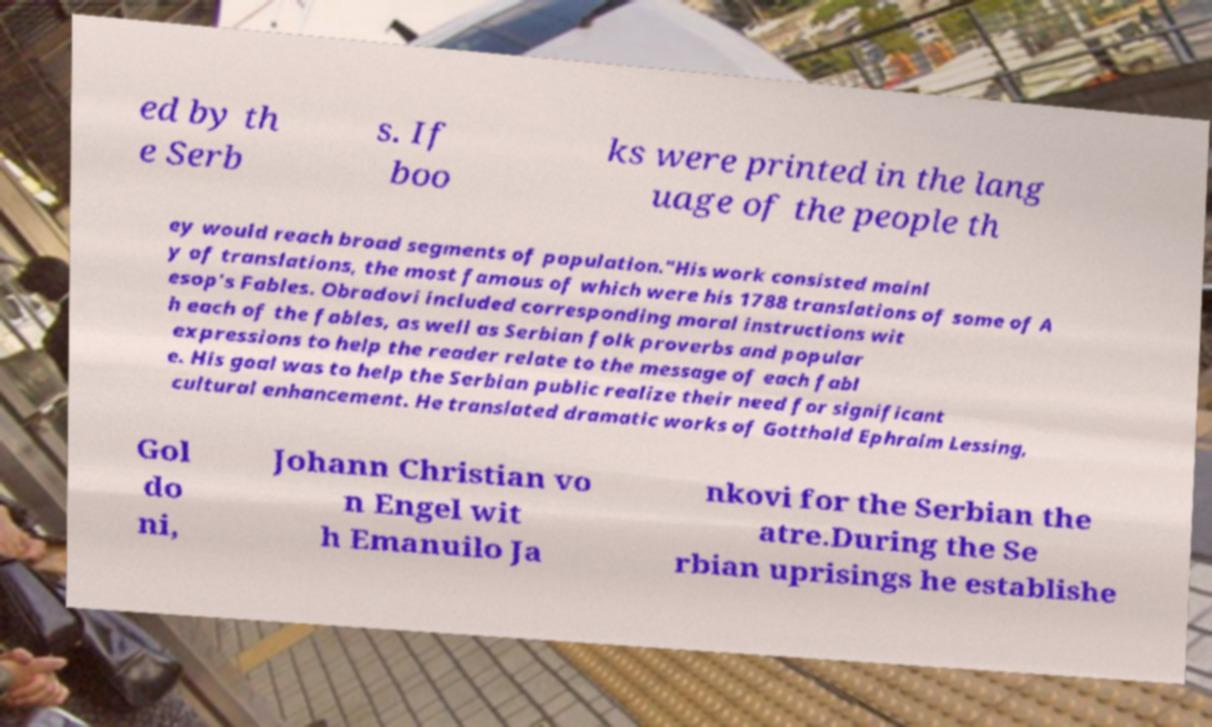Could you assist in decoding the text presented in this image and type it out clearly? ed by th e Serb s. If boo ks were printed in the lang uage of the people th ey would reach broad segments of population."His work consisted mainl y of translations, the most famous of which were his 1788 translations of some of A esop's Fables. Obradovi included corresponding moral instructions wit h each of the fables, as well as Serbian folk proverbs and popular expressions to help the reader relate to the message of each fabl e. His goal was to help the Serbian public realize their need for significant cultural enhancement. He translated dramatic works of Gotthold Ephraim Lessing, Gol do ni, Johann Christian vo n Engel wit h Emanuilo Ja nkovi for the Serbian the atre.During the Se rbian uprisings he establishe 